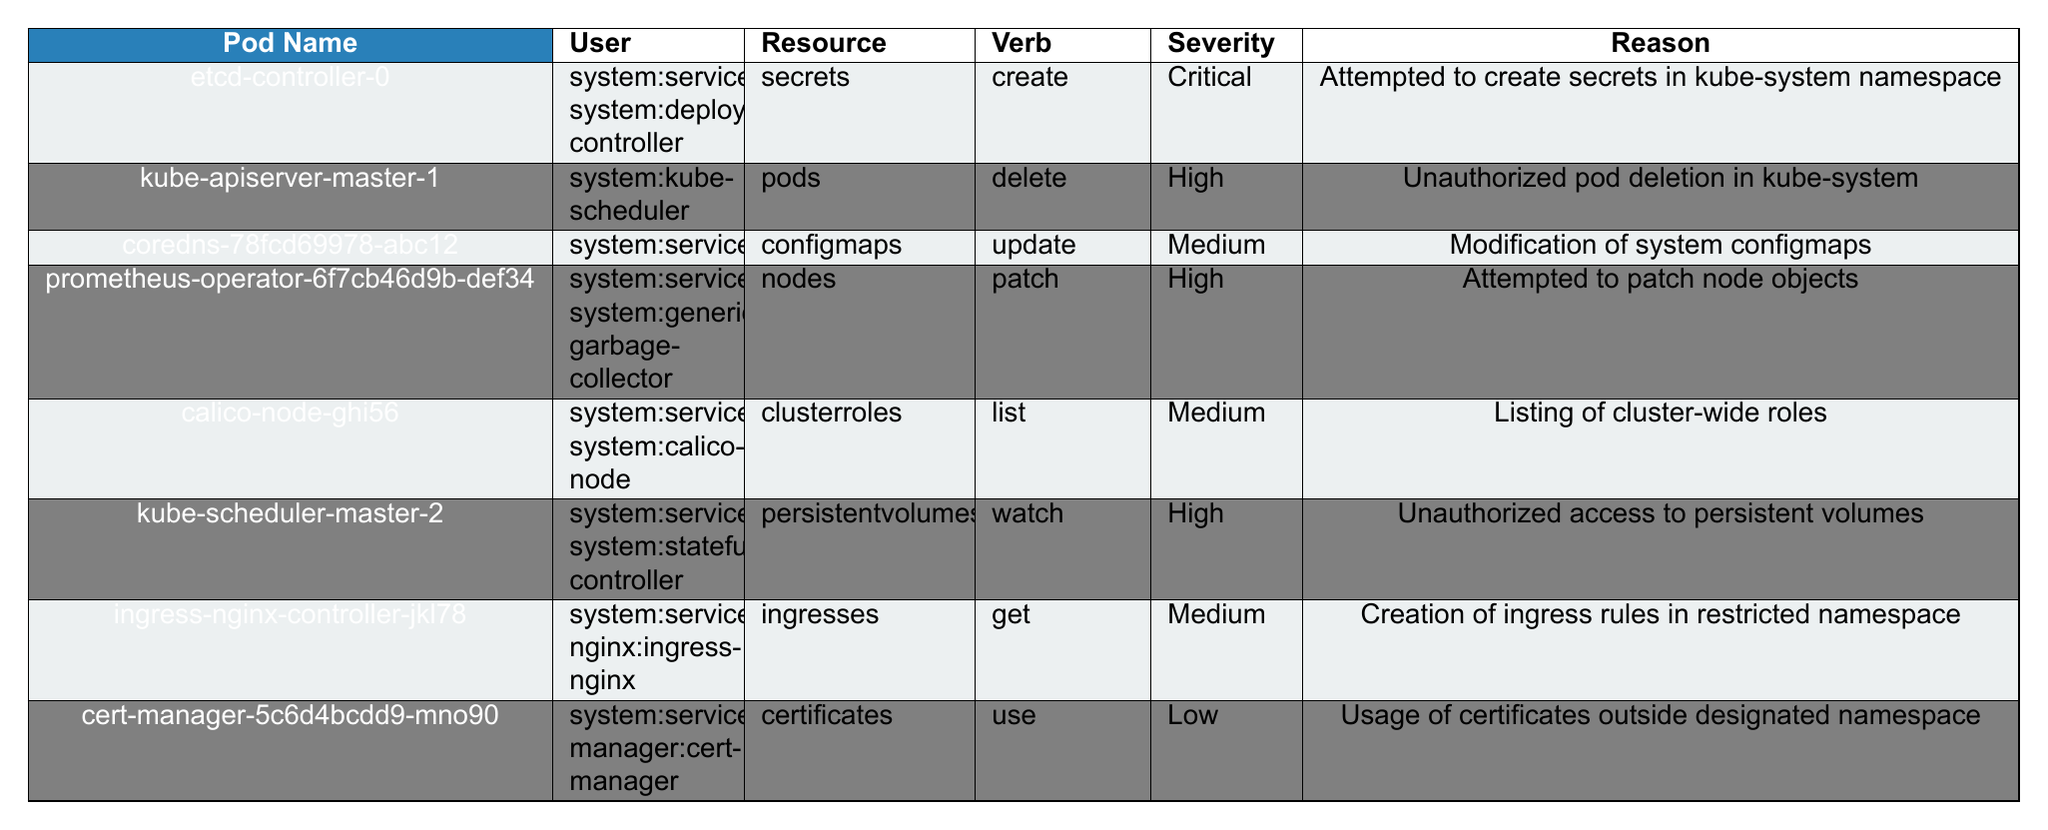What is the pod name associated with the highest severity level? By examining the severity column, the highest severity listed is "Critical", which corresponds to the pod name "etcd-controller-0" in the first row of the table.
Answer: etcd-controller-0 Which user attempted to delete a pod? Looking at the verb column for "delete", the user associated with this action is "system:kube-scheduler", which is in the second row of the table.
Answer: system:kube-scheduler What resource was accessed with a "use" verb? In the table, the verb "use" corresponds to the resource "certificates", which can be found in the last row under the resource column.
Answer: certificates How many attempts were made at "update" actions? There is just one occurrence of the "update" verb in the third row of the table, associated with the resource "configmaps".
Answer: 1 Is there any unauthorized access reported? Yes, "Unauthorized access to persistent volumes" is noted in the sixth row, indicating that unauthorized actions were attempted.
Answer: Yes Who is associated with the attempted creation of secrets? The user responsible for attempting to create secrets in the first row is "system:serviceaccount:kube-system:deployment-controller".
Answer: system:serviceaccount:kube-system:deployment-controller Which namespace had a "High" severity level incident with "patch" action? The incident with a "High" severity level and "patch" action corresponds to the namespace "kube-system", as seen in the fourth row.
Answer: kube-system Count the total number of distinct namespaces mentioned in the table. The namespaces listed are "kube-system", "monitoring", "calico-system", and "ingress-nginx". Counting these gives us 4 distinct namespaces.
Answer: 4 What was the reason for the attempt involving the "list" action? The "list" action was linked to "Listing of cluster-wide roles" as mentioned in the fifth row of the table.
Answer: Listing of cluster-wide roles Is there any instance of a "Medium" severity level associated with an ingress? Yes, the "ingress-nginx-controller-jkl78" attempted to create ingress rules in a restricted namespace, which is classified as "Medium" severity.
Answer: Yes 